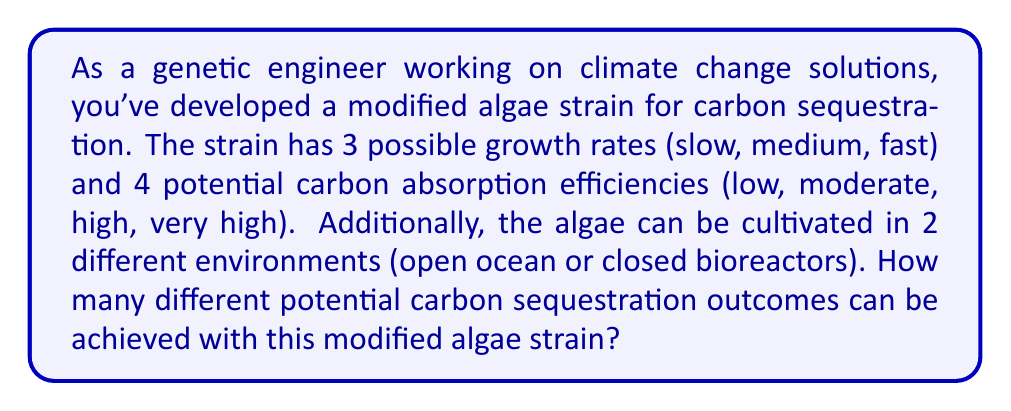Teach me how to tackle this problem. To solve this counting problem, we'll use the multiplication principle of counting. We need to consider the number of options for each characteristic of the algae strain and multiply them together:

1. Growth rates: 3 options (slow, medium, fast)
2. Carbon absorption efficiencies: 4 options (low, moderate, high, very high)
3. Cultivation environments: 2 options (open ocean or closed bioreactors)

Using the multiplication principle:

$$ \text{Total outcomes} = \text{Growth rates} \times \text{Carbon absorption efficiencies} \times \text{Cultivation environments} $$

$$ \text{Total outcomes} = 3 \times 4 \times 2 $$

$$ \text{Total outcomes} = 24 $$

Therefore, there are 24 different potential carbon sequestration outcomes that can be achieved with this modified algae strain.
Answer: 24 potential carbon sequestration outcomes 